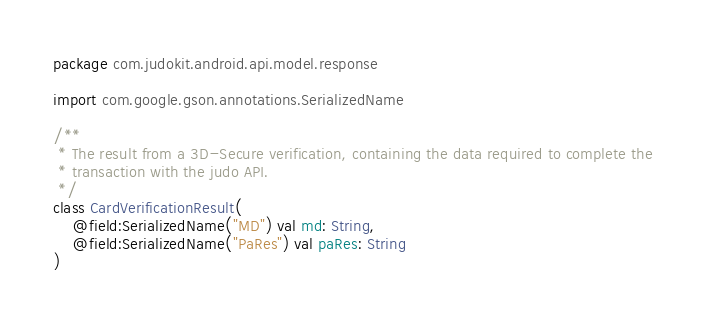Convert code to text. <code><loc_0><loc_0><loc_500><loc_500><_Kotlin_>package com.judokit.android.api.model.response

import com.google.gson.annotations.SerializedName

/**
 * The result from a 3D-Secure verification, containing the data required to complete the
 * transaction with the judo API.
 */
class CardVerificationResult(
    @field:SerializedName("MD") val md: String,
    @field:SerializedName("PaRes") val paRes: String
)
</code> 